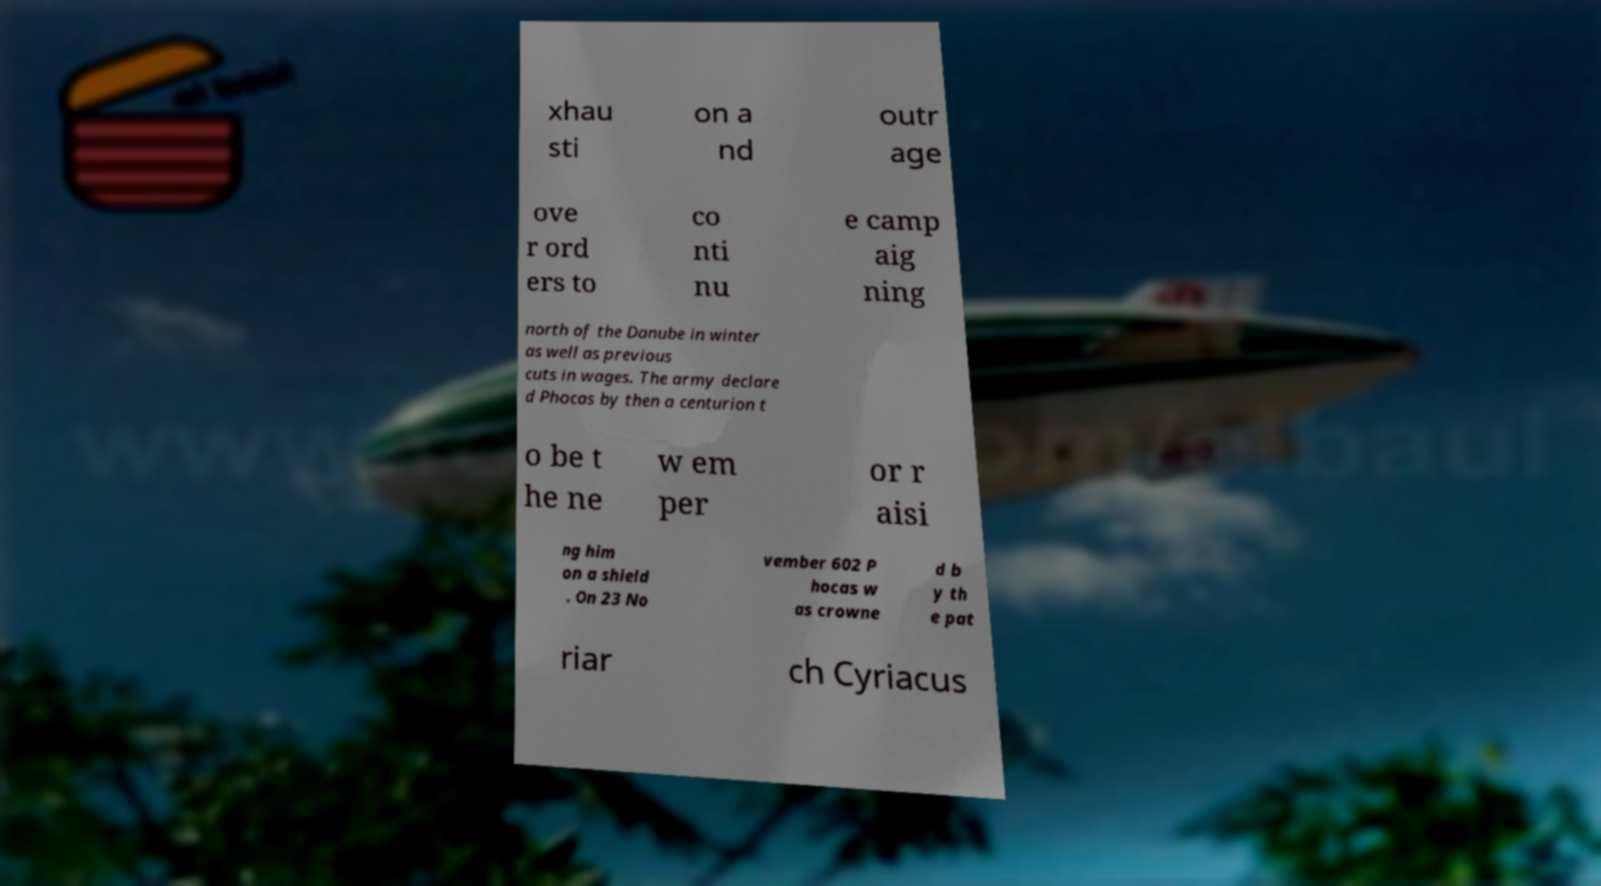I need the written content from this picture converted into text. Can you do that? xhau sti on a nd outr age ove r ord ers to co nti nu e camp aig ning north of the Danube in winter as well as previous cuts in wages. The army declare d Phocas by then a centurion t o be t he ne w em per or r aisi ng him on a shield . On 23 No vember 602 P hocas w as crowne d b y th e pat riar ch Cyriacus 